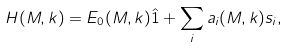Convert formula to latex. <formula><loc_0><loc_0><loc_500><loc_500>H ( M , { k } ) = E _ { 0 } ( M , { k } ) \hat { 1 } + \sum _ { i } a _ { i } ( M , { k } ) s _ { i } ,</formula> 